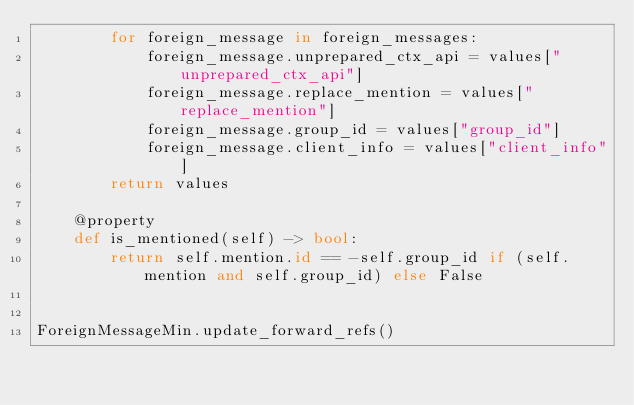Convert code to text. <code><loc_0><loc_0><loc_500><loc_500><_Python_>        for foreign_message in foreign_messages:
            foreign_message.unprepared_ctx_api = values["unprepared_ctx_api"]
            foreign_message.replace_mention = values["replace_mention"]
            foreign_message.group_id = values["group_id"]
            foreign_message.client_info = values["client_info"]
        return values

    @property
    def is_mentioned(self) -> bool:
        return self.mention.id == -self.group_id if (self.mention and self.group_id) else False


ForeignMessageMin.update_forward_refs()
</code> 